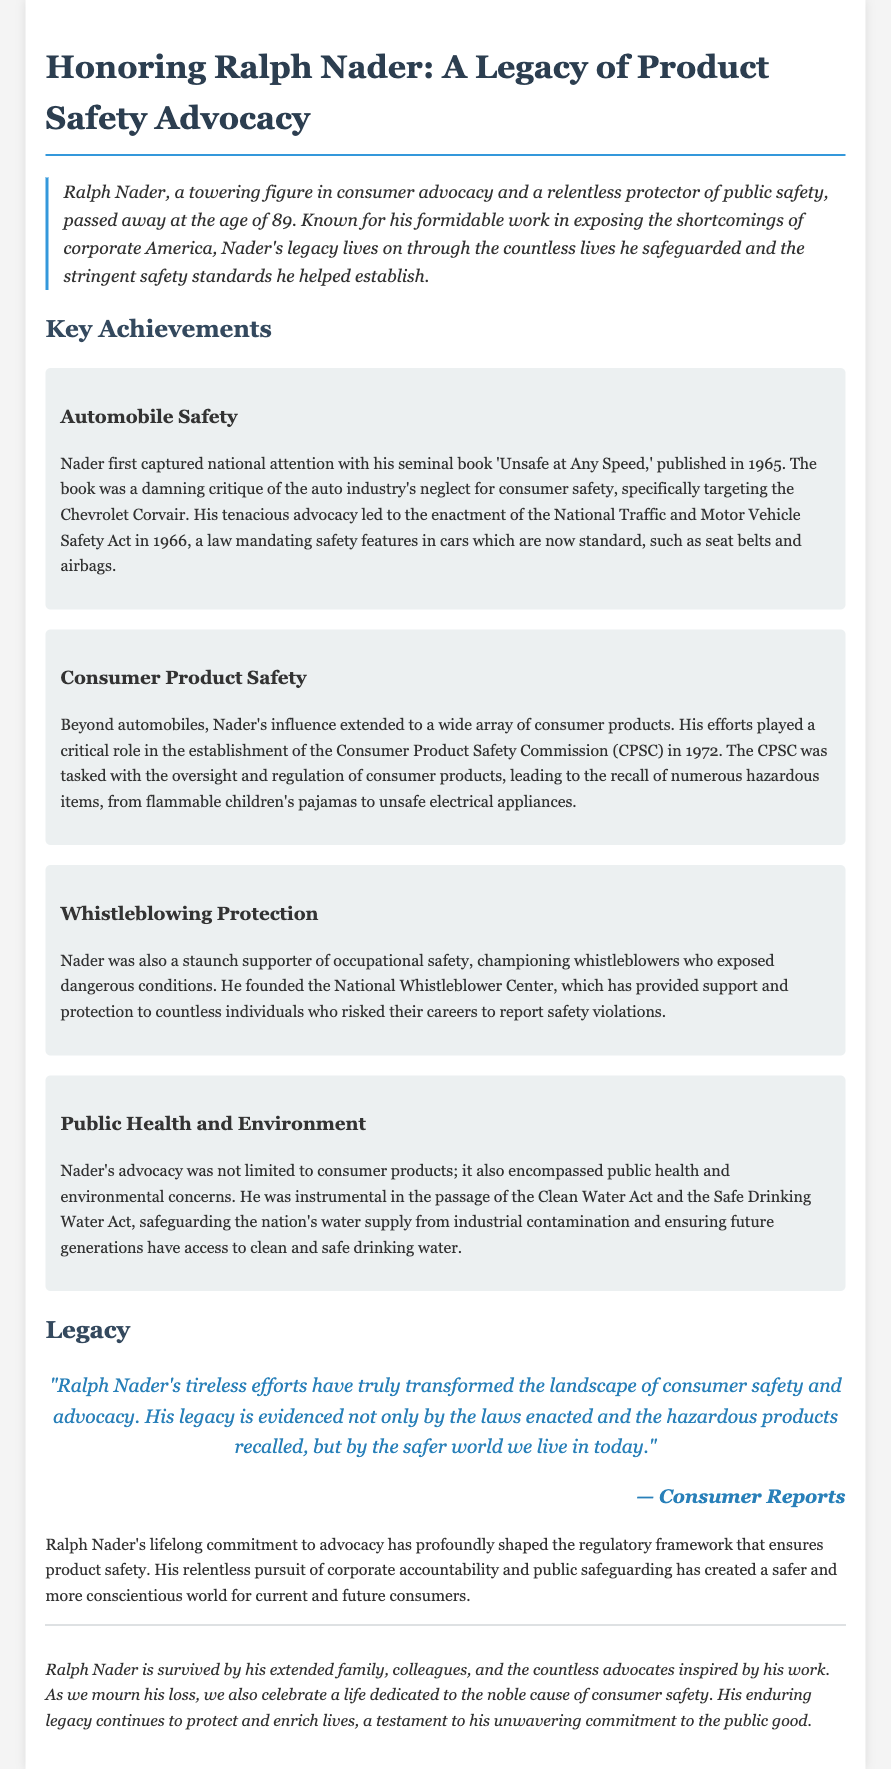What was Ralph Nader's age at the time of his passing? The document states that Ralph Nader passed away at the age of 89.
Answer: 89 What book did Ralph Nader publish in 1965? The document mentions that the book published by Ralph Nader in 1965 is 'Unsafe at Any Speed.'
Answer: 'Unsafe at Any Speed' In which year was the Consumer Product Safety Commission established? The document notes that the Consumer Product Safety Commission was established in 1972.
Answer: 1972 What significant act was passed due to Nader's advocacy in 1966? The document states that Nader's advocacy led to the enactment of the National Traffic and Motor Vehicle Safety Act in 1966.
Answer: National Traffic and Motor Vehicle Safety Act Which water-related acts did Nader influence? The document specifies that Nader was instrumental in the passage of the Clean Water Act and the Safe Drinking Water Act.
Answer: Clean Water Act and Safe Drinking Water Act What major area of safety did Nader focus on besides consumer products? According to the document, Nader also focused on occupational safety and the protection of whistleblowers.
Answer: Occupational safety Which organization did Ralph Nader found for whistleblowers? The document states that Ralph Nader founded the National Whistleblower Center.
Answer: National Whistleblower Center What does the document indicate is a testament to Nader's commitment? The document mentions that Nader's enduring legacy continues to protect and enrich lives as a testament to his unwavering commitment to the public good.
Answer: Public good Who said, "Ralph Nader's tireless efforts have truly transformed the landscape of consumer safety"? The document attributes this quote to Consumer Reports.
Answer: Consumer Reports 